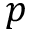<formula> <loc_0><loc_0><loc_500><loc_500>p</formula> 